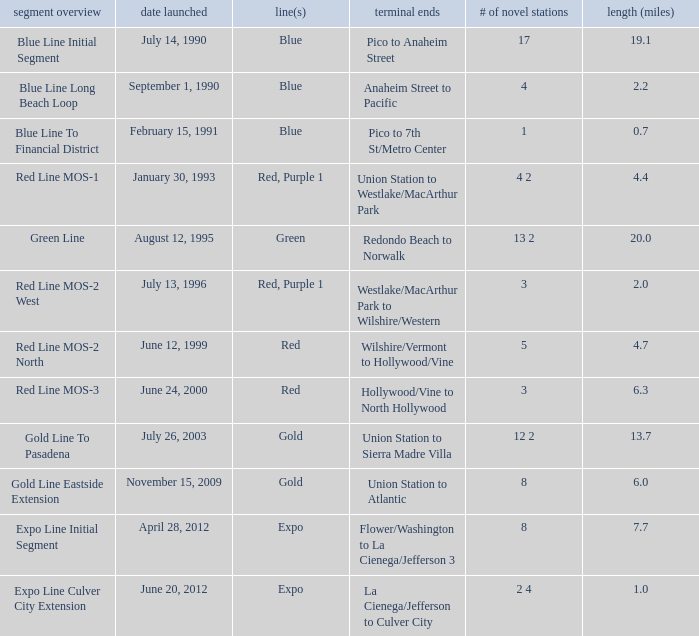What is the length  (miles) when pico to 7th st/metro center are the endpoints? 0.7. 